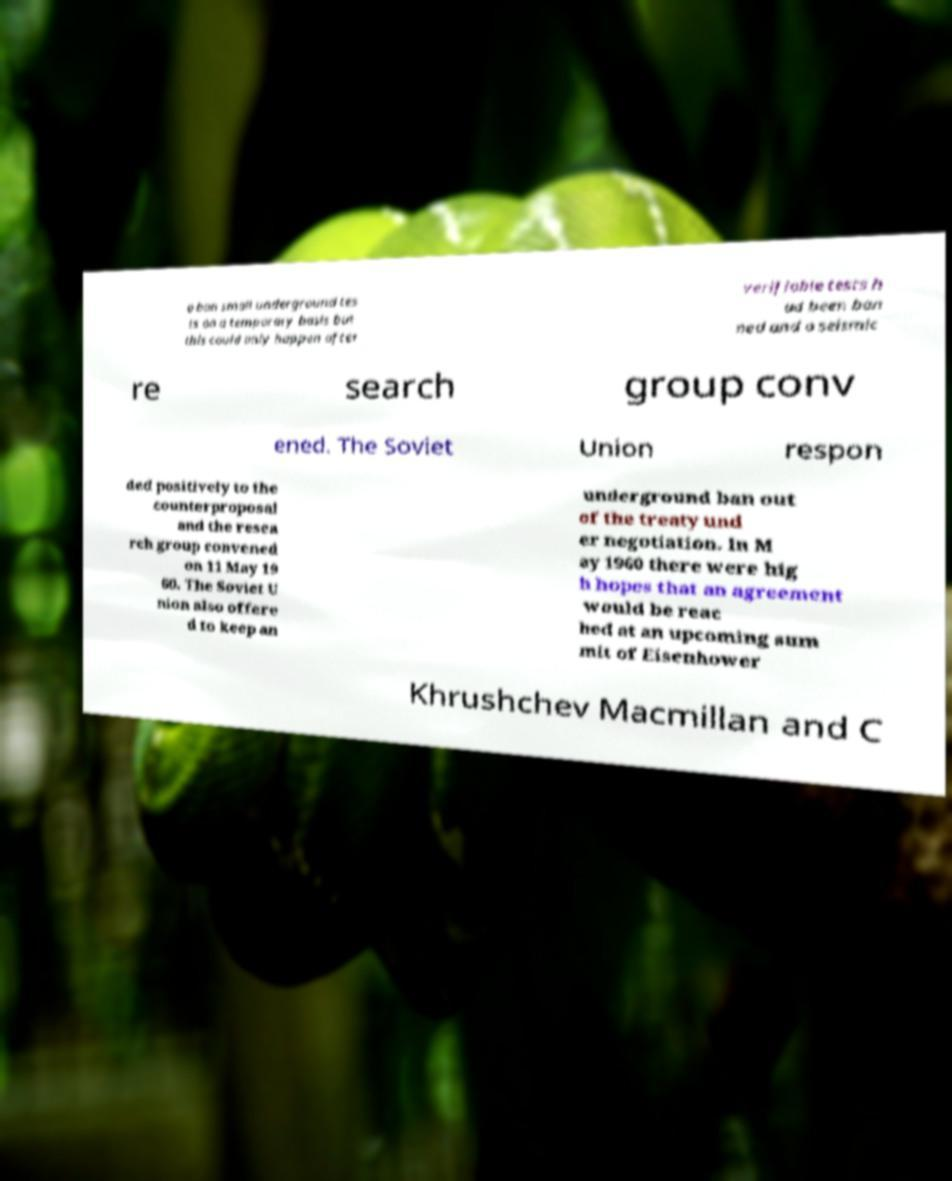I need the written content from this picture converted into text. Can you do that? o ban small underground tes ts on a temporary basis but this could only happen after verifiable tests h ad been ban ned and a seismic re search group conv ened. The Soviet Union respon ded positively to the counterproposal and the resea rch group convened on 11 May 19 60. The Soviet U nion also offere d to keep an underground ban out of the treaty und er negotiation. In M ay 1960 there were hig h hopes that an agreement would be reac hed at an upcoming sum mit of Eisenhower Khrushchev Macmillan and C 